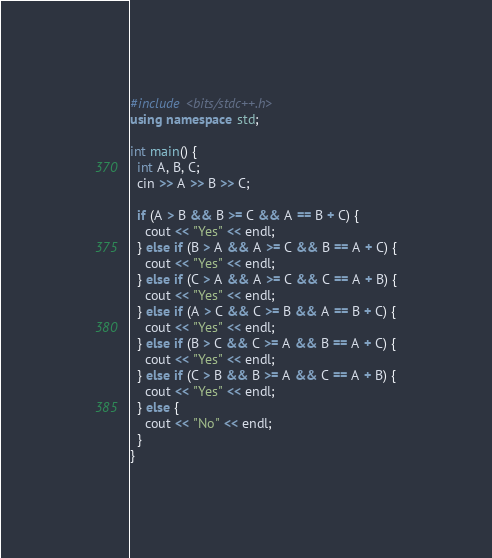Convert code to text. <code><loc_0><loc_0><loc_500><loc_500><_C++_>#include <bits/stdc++.h>
using namespace std;

int main() {
  int A, B, C;
  cin >> A >> B >> C;
  
  if (A > B && B >= C && A == B + C) {
    cout << "Yes" << endl;
  } else if (B > A && A >= C && B == A + C) {
    cout << "Yes" << endl;
  } else if (C > A && A >= C && C == A + B) {
    cout << "Yes" << endl;
  } else if (A > C && C >= B && A == B + C) {
    cout << "Yes" << endl;
  } else if (B > C && C >= A && B == A + C) {
    cout << "Yes" << endl;
  } else if (C > B && B >= A && C == A + B) {
    cout << "Yes" << endl;
  } else {
    cout << "No" << endl;
  }
}
</code> 